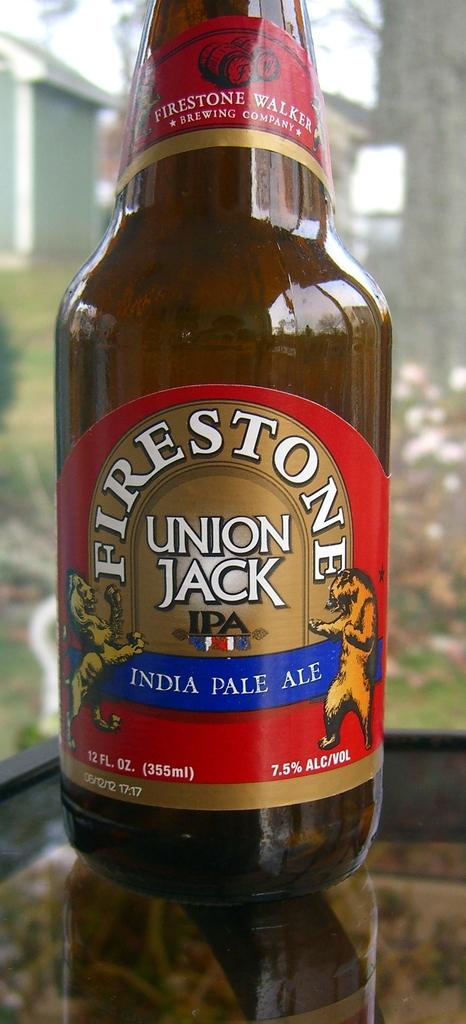<image>
Summarize the visual content of the image. a bottle of firestone union jack india pale ale 